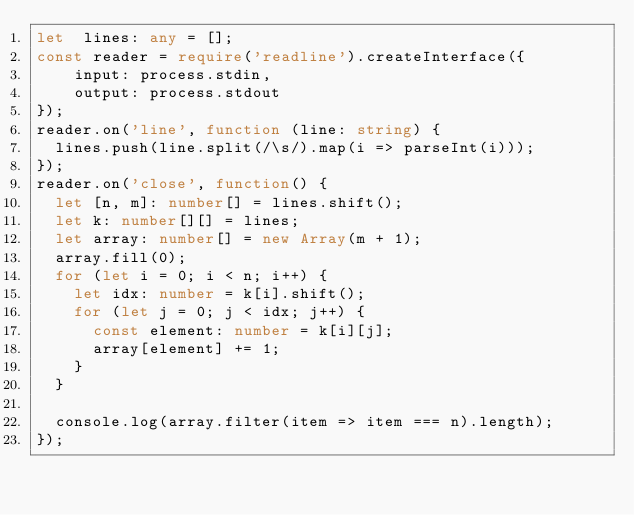Convert code to text. <code><loc_0><loc_0><loc_500><loc_500><_TypeScript_>let  lines: any = [];
const reader = require('readline').createInterface({
    input: process.stdin,
    output: process.stdout
});
reader.on('line', function (line: string) {
  lines.push(line.split(/\s/).map(i => parseInt(i)));
});
reader.on('close', function() {
  let [n, m]: number[] = lines.shift();
  let k: number[][] = lines;
  let array: number[] = new Array(m + 1);
  array.fill(0);
  for (let i = 0; i < n; i++) {
    let idx: number = k[i].shift();
    for (let j = 0; j < idx; j++) {
      const element: number = k[i][j];
      array[element] += 1;
    }
  }
  
  console.log(array.filter(item => item === n).length);
});</code> 